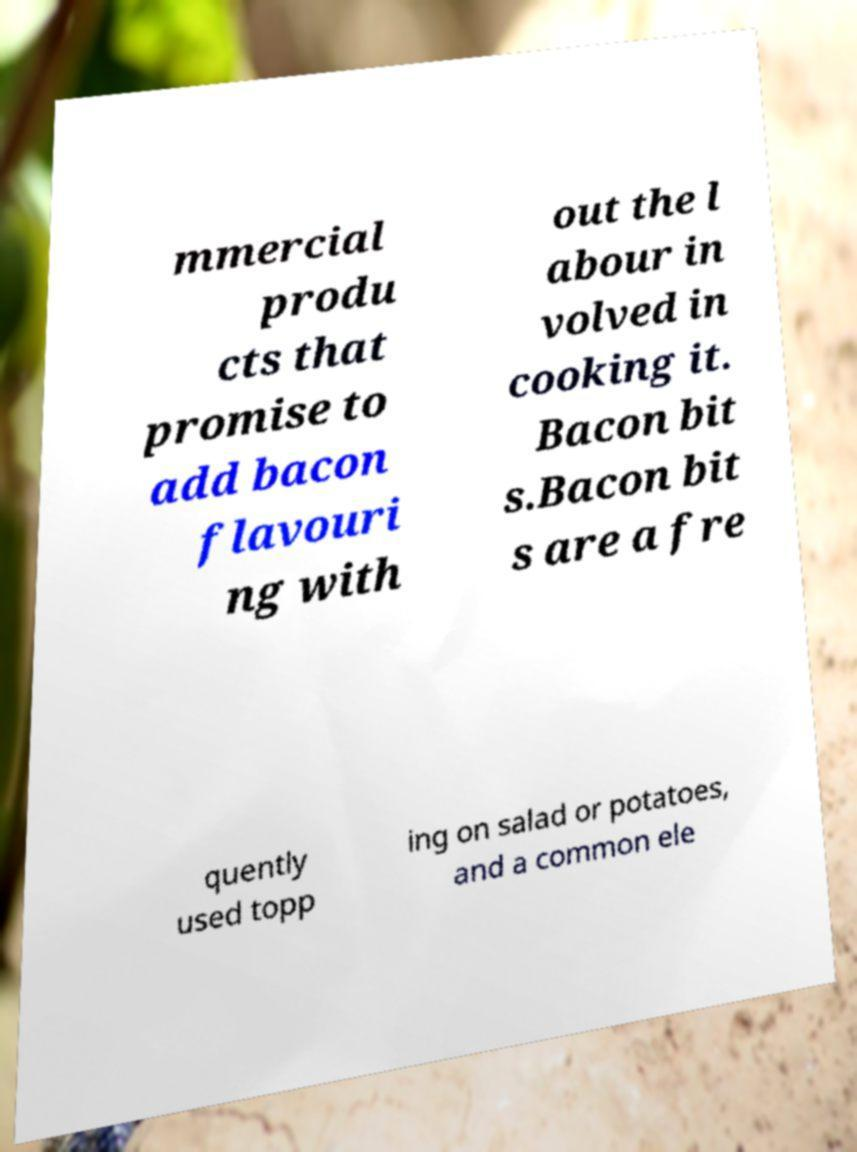I need the written content from this picture converted into text. Can you do that? mmercial produ cts that promise to add bacon flavouri ng with out the l abour in volved in cooking it. Bacon bit s.Bacon bit s are a fre quently used topp ing on salad or potatoes, and a common ele 